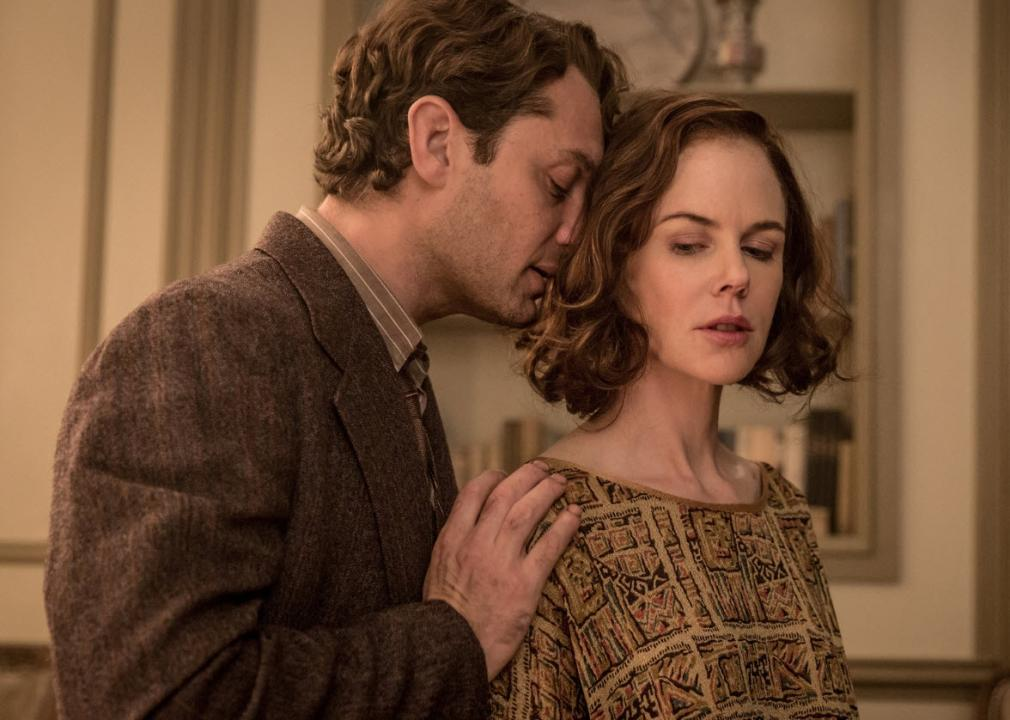What are the characters thinking in this moment? In this scene, the character portrayed by Jude Law might be contemplating a deep admiration or a critical personal revelation to share with Nicole Kidman's character, reflecting a moment of vulnerability and connection. Kidman's character, turning slightly away, shows a mixture of restraint and contemplation, possibly weighing the consequences of a professional decision or personal affair that affects their relationship. 